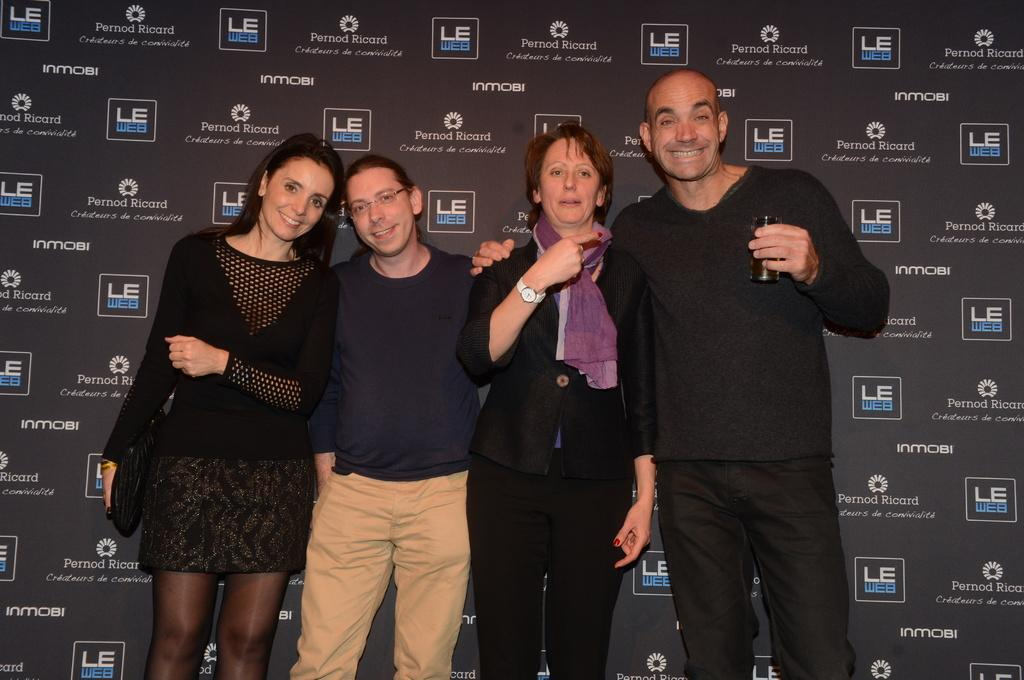How many people are present in the image? There are four people standing in the image. What is the facial expression of most of the people? Three of the people are smiling. What object is a man holding in the image? A man is holding a glass. What object is a woman holding in the image? A woman is holding a scarf. What can be seen in the background of the image? There is a hoarding visible in the background. Can you see a boat in the image? No, there is no boat present in the image. Is there a volcano visible in the background of the image? No, there is no volcano visible in the background of the image. 